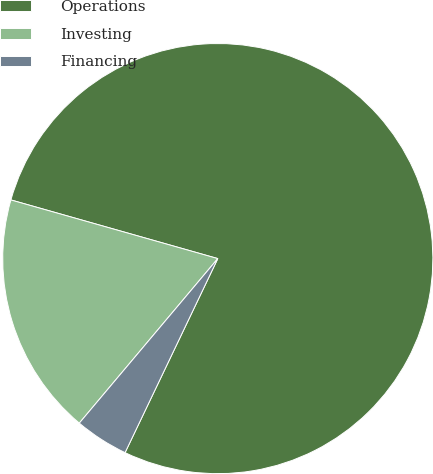<chart> <loc_0><loc_0><loc_500><loc_500><pie_chart><fcel>Operations<fcel>Investing<fcel>Financing<nl><fcel>77.69%<fcel>18.26%<fcel>4.04%<nl></chart> 